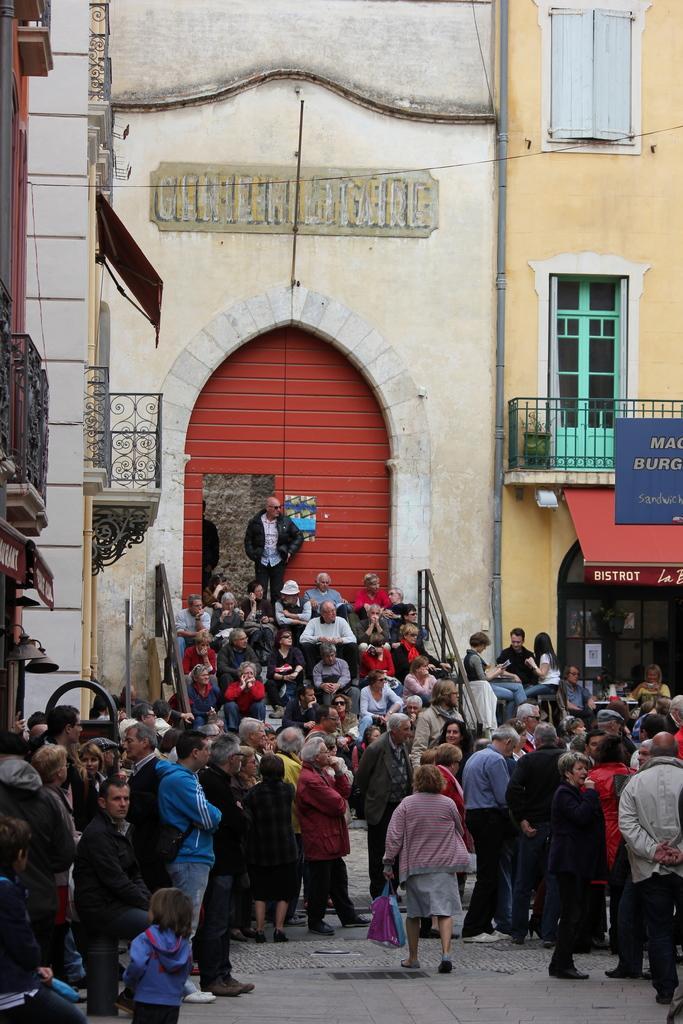Describe this image in one or two sentences. In this picture there are few persons standing and there are few other persons sitting on a stair case and there are buildings on either sides of them. 